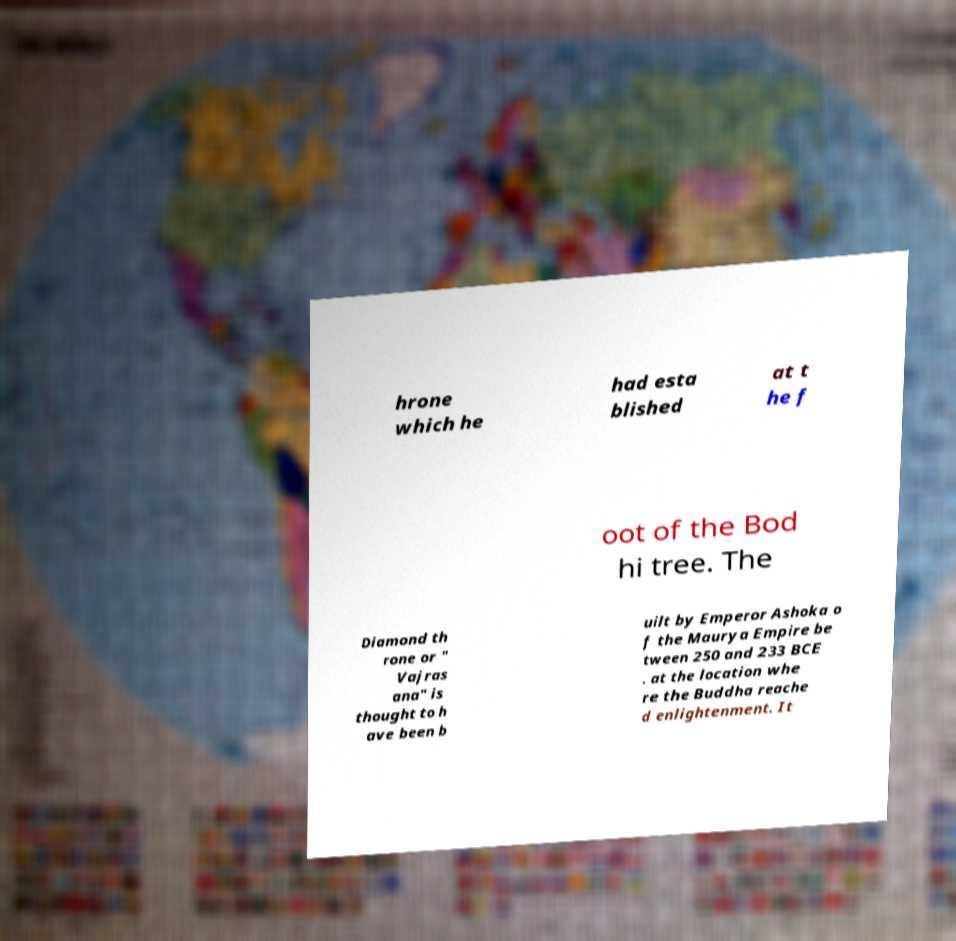Could you extract and type out the text from this image? hrone which he had esta blished at t he f oot of the Bod hi tree. The Diamond th rone or " Vajras ana" is thought to h ave been b uilt by Emperor Ashoka o f the Maurya Empire be tween 250 and 233 BCE . at the location whe re the Buddha reache d enlightenment. It 